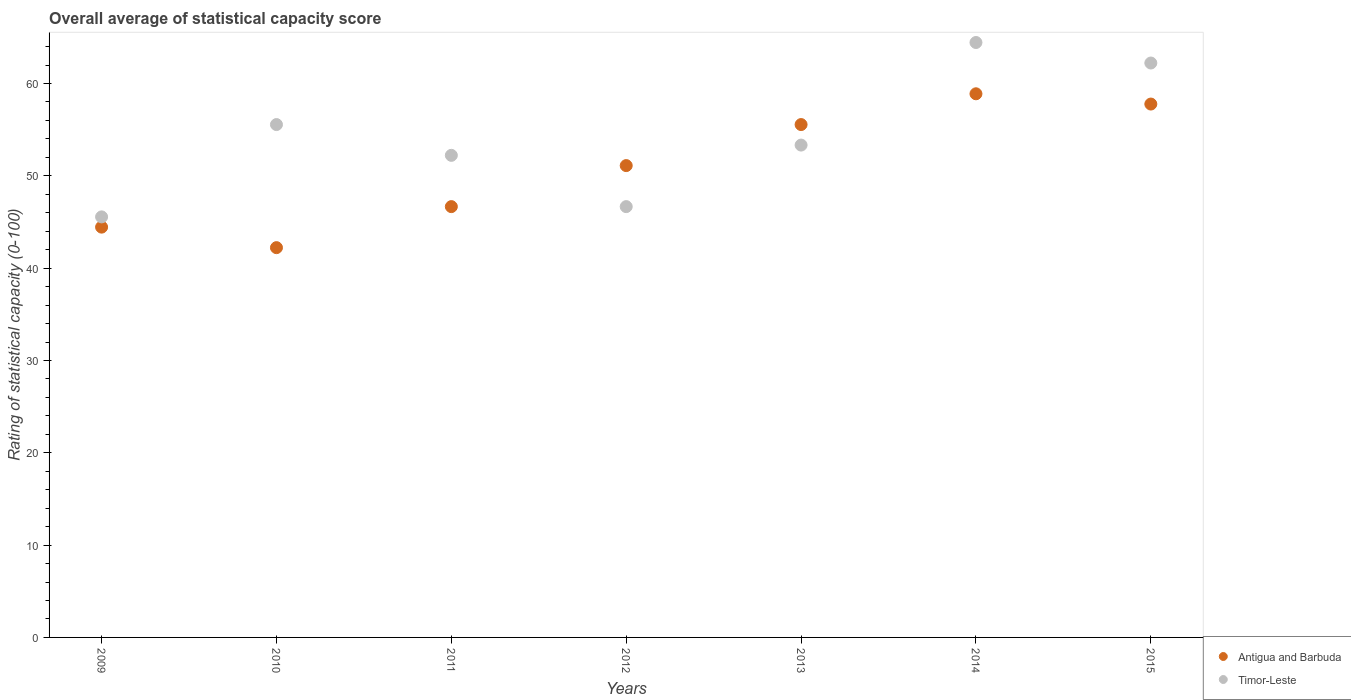How many different coloured dotlines are there?
Your answer should be compact. 2. Is the number of dotlines equal to the number of legend labels?
Keep it short and to the point. Yes. What is the rating of statistical capacity in Timor-Leste in 2011?
Ensure brevity in your answer.  52.22. Across all years, what is the maximum rating of statistical capacity in Antigua and Barbuda?
Your answer should be very brief. 58.89. Across all years, what is the minimum rating of statistical capacity in Antigua and Barbuda?
Your answer should be very brief. 42.22. In which year was the rating of statistical capacity in Antigua and Barbuda maximum?
Make the answer very short. 2014. What is the total rating of statistical capacity in Timor-Leste in the graph?
Your response must be concise. 380. What is the difference between the rating of statistical capacity in Timor-Leste in 2012 and that in 2014?
Your answer should be compact. -17.78. What is the difference between the rating of statistical capacity in Timor-Leste in 2013 and the rating of statistical capacity in Antigua and Barbuda in 2010?
Ensure brevity in your answer.  11.11. What is the average rating of statistical capacity in Timor-Leste per year?
Keep it short and to the point. 54.29. In the year 2013, what is the difference between the rating of statistical capacity in Timor-Leste and rating of statistical capacity in Antigua and Barbuda?
Offer a terse response. -2.22. What is the ratio of the rating of statistical capacity in Timor-Leste in 2009 to that in 2011?
Give a very brief answer. 0.87. Is the difference between the rating of statistical capacity in Timor-Leste in 2013 and 2015 greater than the difference between the rating of statistical capacity in Antigua and Barbuda in 2013 and 2015?
Ensure brevity in your answer.  No. What is the difference between the highest and the second highest rating of statistical capacity in Antigua and Barbuda?
Ensure brevity in your answer.  1.11. What is the difference between the highest and the lowest rating of statistical capacity in Antigua and Barbuda?
Offer a very short reply. 16.67. Is the sum of the rating of statistical capacity in Antigua and Barbuda in 2012 and 2013 greater than the maximum rating of statistical capacity in Timor-Leste across all years?
Keep it short and to the point. Yes. Is the rating of statistical capacity in Timor-Leste strictly greater than the rating of statistical capacity in Antigua and Barbuda over the years?
Keep it short and to the point. No. What is the difference between two consecutive major ticks on the Y-axis?
Keep it short and to the point. 10. Are the values on the major ticks of Y-axis written in scientific E-notation?
Offer a terse response. No. Does the graph contain any zero values?
Provide a succinct answer. No. Does the graph contain grids?
Your response must be concise. No. Where does the legend appear in the graph?
Your response must be concise. Bottom right. How many legend labels are there?
Offer a terse response. 2. How are the legend labels stacked?
Offer a very short reply. Vertical. What is the title of the graph?
Your answer should be very brief. Overall average of statistical capacity score. What is the label or title of the X-axis?
Offer a very short reply. Years. What is the label or title of the Y-axis?
Keep it short and to the point. Rating of statistical capacity (0-100). What is the Rating of statistical capacity (0-100) in Antigua and Barbuda in 2009?
Provide a succinct answer. 44.44. What is the Rating of statistical capacity (0-100) in Timor-Leste in 2009?
Your response must be concise. 45.56. What is the Rating of statistical capacity (0-100) in Antigua and Barbuda in 2010?
Offer a terse response. 42.22. What is the Rating of statistical capacity (0-100) in Timor-Leste in 2010?
Keep it short and to the point. 55.56. What is the Rating of statistical capacity (0-100) in Antigua and Barbuda in 2011?
Ensure brevity in your answer.  46.67. What is the Rating of statistical capacity (0-100) in Timor-Leste in 2011?
Give a very brief answer. 52.22. What is the Rating of statistical capacity (0-100) of Antigua and Barbuda in 2012?
Your response must be concise. 51.11. What is the Rating of statistical capacity (0-100) of Timor-Leste in 2012?
Offer a very short reply. 46.67. What is the Rating of statistical capacity (0-100) of Antigua and Barbuda in 2013?
Keep it short and to the point. 55.56. What is the Rating of statistical capacity (0-100) in Timor-Leste in 2013?
Provide a short and direct response. 53.33. What is the Rating of statistical capacity (0-100) in Antigua and Barbuda in 2014?
Keep it short and to the point. 58.89. What is the Rating of statistical capacity (0-100) of Timor-Leste in 2014?
Ensure brevity in your answer.  64.44. What is the Rating of statistical capacity (0-100) in Antigua and Barbuda in 2015?
Provide a succinct answer. 57.78. What is the Rating of statistical capacity (0-100) in Timor-Leste in 2015?
Provide a succinct answer. 62.22. Across all years, what is the maximum Rating of statistical capacity (0-100) in Antigua and Barbuda?
Keep it short and to the point. 58.89. Across all years, what is the maximum Rating of statistical capacity (0-100) of Timor-Leste?
Make the answer very short. 64.44. Across all years, what is the minimum Rating of statistical capacity (0-100) of Antigua and Barbuda?
Provide a short and direct response. 42.22. Across all years, what is the minimum Rating of statistical capacity (0-100) in Timor-Leste?
Provide a short and direct response. 45.56. What is the total Rating of statistical capacity (0-100) of Antigua and Barbuda in the graph?
Ensure brevity in your answer.  356.67. What is the total Rating of statistical capacity (0-100) of Timor-Leste in the graph?
Keep it short and to the point. 380. What is the difference between the Rating of statistical capacity (0-100) in Antigua and Barbuda in 2009 and that in 2010?
Your response must be concise. 2.22. What is the difference between the Rating of statistical capacity (0-100) in Antigua and Barbuda in 2009 and that in 2011?
Offer a terse response. -2.22. What is the difference between the Rating of statistical capacity (0-100) of Timor-Leste in 2009 and that in 2011?
Your answer should be very brief. -6.67. What is the difference between the Rating of statistical capacity (0-100) in Antigua and Barbuda in 2009 and that in 2012?
Ensure brevity in your answer.  -6.67. What is the difference between the Rating of statistical capacity (0-100) of Timor-Leste in 2009 and that in 2012?
Provide a succinct answer. -1.11. What is the difference between the Rating of statistical capacity (0-100) in Antigua and Barbuda in 2009 and that in 2013?
Provide a succinct answer. -11.11. What is the difference between the Rating of statistical capacity (0-100) in Timor-Leste in 2009 and that in 2013?
Ensure brevity in your answer.  -7.78. What is the difference between the Rating of statistical capacity (0-100) in Antigua and Barbuda in 2009 and that in 2014?
Your response must be concise. -14.44. What is the difference between the Rating of statistical capacity (0-100) of Timor-Leste in 2009 and that in 2014?
Give a very brief answer. -18.89. What is the difference between the Rating of statistical capacity (0-100) in Antigua and Barbuda in 2009 and that in 2015?
Offer a terse response. -13.33. What is the difference between the Rating of statistical capacity (0-100) of Timor-Leste in 2009 and that in 2015?
Make the answer very short. -16.67. What is the difference between the Rating of statistical capacity (0-100) in Antigua and Barbuda in 2010 and that in 2011?
Make the answer very short. -4.44. What is the difference between the Rating of statistical capacity (0-100) in Antigua and Barbuda in 2010 and that in 2012?
Your answer should be compact. -8.89. What is the difference between the Rating of statistical capacity (0-100) in Timor-Leste in 2010 and that in 2012?
Make the answer very short. 8.89. What is the difference between the Rating of statistical capacity (0-100) of Antigua and Barbuda in 2010 and that in 2013?
Your response must be concise. -13.33. What is the difference between the Rating of statistical capacity (0-100) in Timor-Leste in 2010 and that in 2013?
Provide a succinct answer. 2.22. What is the difference between the Rating of statistical capacity (0-100) in Antigua and Barbuda in 2010 and that in 2014?
Ensure brevity in your answer.  -16.67. What is the difference between the Rating of statistical capacity (0-100) in Timor-Leste in 2010 and that in 2014?
Provide a short and direct response. -8.89. What is the difference between the Rating of statistical capacity (0-100) in Antigua and Barbuda in 2010 and that in 2015?
Offer a terse response. -15.56. What is the difference between the Rating of statistical capacity (0-100) of Timor-Leste in 2010 and that in 2015?
Your answer should be very brief. -6.67. What is the difference between the Rating of statistical capacity (0-100) in Antigua and Barbuda in 2011 and that in 2012?
Your answer should be very brief. -4.44. What is the difference between the Rating of statistical capacity (0-100) of Timor-Leste in 2011 and that in 2012?
Your answer should be compact. 5.56. What is the difference between the Rating of statistical capacity (0-100) in Antigua and Barbuda in 2011 and that in 2013?
Provide a short and direct response. -8.89. What is the difference between the Rating of statistical capacity (0-100) in Timor-Leste in 2011 and that in 2013?
Provide a succinct answer. -1.11. What is the difference between the Rating of statistical capacity (0-100) in Antigua and Barbuda in 2011 and that in 2014?
Offer a terse response. -12.22. What is the difference between the Rating of statistical capacity (0-100) of Timor-Leste in 2011 and that in 2014?
Your answer should be compact. -12.22. What is the difference between the Rating of statistical capacity (0-100) of Antigua and Barbuda in 2011 and that in 2015?
Your answer should be very brief. -11.11. What is the difference between the Rating of statistical capacity (0-100) in Timor-Leste in 2011 and that in 2015?
Your answer should be compact. -10. What is the difference between the Rating of statistical capacity (0-100) in Antigua and Barbuda in 2012 and that in 2013?
Make the answer very short. -4.44. What is the difference between the Rating of statistical capacity (0-100) in Timor-Leste in 2012 and that in 2013?
Ensure brevity in your answer.  -6.67. What is the difference between the Rating of statistical capacity (0-100) in Antigua and Barbuda in 2012 and that in 2014?
Offer a very short reply. -7.78. What is the difference between the Rating of statistical capacity (0-100) of Timor-Leste in 2012 and that in 2014?
Your response must be concise. -17.78. What is the difference between the Rating of statistical capacity (0-100) of Antigua and Barbuda in 2012 and that in 2015?
Give a very brief answer. -6.67. What is the difference between the Rating of statistical capacity (0-100) in Timor-Leste in 2012 and that in 2015?
Your answer should be compact. -15.56. What is the difference between the Rating of statistical capacity (0-100) of Timor-Leste in 2013 and that in 2014?
Provide a short and direct response. -11.11. What is the difference between the Rating of statistical capacity (0-100) of Antigua and Barbuda in 2013 and that in 2015?
Offer a very short reply. -2.22. What is the difference between the Rating of statistical capacity (0-100) in Timor-Leste in 2013 and that in 2015?
Make the answer very short. -8.89. What is the difference between the Rating of statistical capacity (0-100) in Timor-Leste in 2014 and that in 2015?
Your answer should be very brief. 2.22. What is the difference between the Rating of statistical capacity (0-100) of Antigua and Barbuda in 2009 and the Rating of statistical capacity (0-100) of Timor-Leste in 2010?
Keep it short and to the point. -11.11. What is the difference between the Rating of statistical capacity (0-100) in Antigua and Barbuda in 2009 and the Rating of statistical capacity (0-100) in Timor-Leste in 2011?
Keep it short and to the point. -7.78. What is the difference between the Rating of statistical capacity (0-100) in Antigua and Barbuda in 2009 and the Rating of statistical capacity (0-100) in Timor-Leste in 2012?
Make the answer very short. -2.22. What is the difference between the Rating of statistical capacity (0-100) of Antigua and Barbuda in 2009 and the Rating of statistical capacity (0-100) of Timor-Leste in 2013?
Your answer should be very brief. -8.89. What is the difference between the Rating of statistical capacity (0-100) in Antigua and Barbuda in 2009 and the Rating of statistical capacity (0-100) in Timor-Leste in 2014?
Give a very brief answer. -20. What is the difference between the Rating of statistical capacity (0-100) in Antigua and Barbuda in 2009 and the Rating of statistical capacity (0-100) in Timor-Leste in 2015?
Provide a short and direct response. -17.78. What is the difference between the Rating of statistical capacity (0-100) of Antigua and Barbuda in 2010 and the Rating of statistical capacity (0-100) of Timor-Leste in 2011?
Offer a very short reply. -10. What is the difference between the Rating of statistical capacity (0-100) in Antigua and Barbuda in 2010 and the Rating of statistical capacity (0-100) in Timor-Leste in 2012?
Offer a terse response. -4.44. What is the difference between the Rating of statistical capacity (0-100) of Antigua and Barbuda in 2010 and the Rating of statistical capacity (0-100) of Timor-Leste in 2013?
Your answer should be very brief. -11.11. What is the difference between the Rating of statistical capacity (0-100) of Antigua and Barbuda in 2010 and the Rating of statistical capacity (0-100) of Timor-Leste in 2014?
Ensure brevity in your answer.  -22.22. What is the difference between the Rating of statistical capacity (0-100) in Antigua and Barbuda in 2010 and the Rating of statistical capacity (0-100) in Timor-Leste in 2015?
Your response must be concise. -20. What is the difference between the Rating of statistical capacity (0-100) in Antigua and Barbuda in 2011 and the Rating of statistical capacity (0-100) in Timor-Leste in 2013?
Ensure brevity in your answer.  -6.67. What is the difference between the Rating of statistical capacity (0-100) in Antigua and Barbuda in 2011 and the Rating of statistical capacity (0-100) in Timor-Leste in 2014?
Give a very brief answer. -17.78. What is the difference between the Rating of statistical capacity (0-100) of Antigua and Barbuda in 2011 and the Rating of statistical capacity (0-100) of Timor-Leste in 2015?
Your response must be concise. -15.56. What is the difference between the Rating of statistical capacity (0-100) of Antigua and Barbuda in 2012 and the Rating of statistical capacity (0-100) of Timor-Leste in 2013?
Ensure brevity in your answer.  -2.22. What is the difference between the Rating of statistical capacity (0-100) in Antigua and Barbuda in 2012 and the Rating of statistical capacity (0-100) in Timor-Leste in 2014?
Offer a very short reply. -13.33. What is the difference between the Rating of statistical capacity (0-100) of Antigua and Barbuda in 2012 and the Rating of statistical capacity (0-100) of Timor-Leste in 2015?
Your response must be concise. -11.11. What is the difference between the Rating of statistical capacity (0-100) of Antigua and Barbuda in 2013 and the Rating of statistical capacity (0-100) of Timor-Leste in 2014?
Provide a succinct answer. -8.89. What is the difference between the Rating of statistical capacity (0-100) of Antigua and Barbuda in 2013 and the Rating of statistical capacity (0-100) of Timor-Leste in 2015?
Offer a very short reply. -6.67. What is the difference between the Rating of statistical capacity (0-100) in Antigua and Barbuda in 2014 and the Rating of statistical capacity (0-100) in Timor-Leste in 2015?
Your answer should be compact. -3.33. What is the average Rating of statistical capacity (0-100) of Antigua and Barbuda per year?
Provide a succinct answer. 50.95. What is the average Rating of statistical capacity (0-100) of Timor-Leste per year?
Offer a very short reply. 54.29. In the year 2009, what is the difference between the Rating of statistical capacity (0-100) in Antigua and Barbuda and Rating of statistical capacity (0-100) in Timor-Leste?
Ensure brevity in your answer.  -1.11. In the year 2010, what is the difference between the Rating of statistical capacity (0-100) of Antigua and Barbuda and Rating of statistical capacity (0-100) of Timor-Leste?
Offer a terse response. -13.33. In the year 2011, what is the difference between the Rating of statistical capacity (0-100) of Antigua and Barbuda and Rating of statistical capacity (0-100) of Timor-Leste?
Offer a terse response. -5.56. In the year 2012, what is the difference between the Rating of statistical capacity (0-100) of Antigua and Barbuda and Rating of statistical capacity (0-100) of Timor-Leste?
Make the answer very short. 4.44. In the year 2013, what is the difference between the Rating of statistical capacity (0-100) in Antigua and Barbuda and Rating of statistical capacity (0-100) in Timor-Leste?
Offer a terse response. 2.22. In the year 2014, what is the difference between the Rating of statistical capacity (0-100) of Antigua and Barbuda and Rating of statistical capacity (0-100) of Timor-Leste?
Offer a terse response. -5.56. In the year 2015, what is the difference between the Rating of statistical capacity (0-100) in Antigua and Barbuda and Rating of statistical capacity (0-100) in Timor-Leste?
Your answer should be compact. -4.44. What is the ratio of the Rating of statistical capacity (0-100) in Antigua and Barbuda in 2009 to that in 2010?
Your answer should be very brief. 1.05. What is the ratio of the Rating of statistical capacity (0-100) of Timor-Leste in 2009 to that in 2010?
Your answer should be very brief. 0.82. What is the ratio of the Rating of statistical capacity (0-100) in Antigua and Barbuda in 2009 to that in 2011?
Provide a succinct answer. 0.95. What is the ratio of the Rating of statistical capacity (0-100) in Timor-Leste in 2009 to that in 2011?
Offer a very short reply. 0.87. What is the ratio of the Rating of statistical capacity (0-100) in Antigua and Barbuda in 2009 to that in 2012?
Provide a short and direct response. 0.87. What is the ratio of the Rating of statistical capacity (0-100) in Timor-Leste in 2009 to that in 2012?
Your response must be concise. 0.98. What is the ratio of the Rating of statistical capacity (0-100) of Timor-Leste in 2009 to that in 2013?
Provide a succinct answer. 0.85. What is the ratio of the Rating of statistical capacity (0-100) of Antigua and Barbuda in 2009 to that in 2014?
Provide a succinct answer. 0.75. What is the ratio of the Rating of statistical capacity (0-100) in Timor-Leste in 2009 to that in 2014?
Provide a succinct answer. 0.71. What is the ratio of the Rating of statistical capacity (0-100) in Antigua and Barbuda in 2009 to that in 2015?
Give a very brief answer. 0.77. What is the ratio of the Rating of statistical capacity (0-100) of Timor-Leste in 2009 to that in 2015?
Your answer should be very brief. 0.73. What is the ratio of the Rating of statistical capacity (0-100) of Antigua and Barbuda in 2010 to that in 2011?
Offer a terse response. 0.9. What is the ratio of the Rating of statistical capacity (0-100) in Timor-Leste in 2010 to that in 2011?
Ensure brevity in your answer.  1.06. What is the ratio of the Rating of statistical capacity (0-100) in Antigua and Barbuda in 2010 to that in 2012?
Your answer should be very brief. 0.83. What is the ratio of the Rating of statistical capacity (0-100) in Timor-Leste in 2010 to that in 2012?
Offer a terse response. 1.19. What is the ratio of the Rating of statistical capacity (0-100) of Antigua and Barbuda in 2010 to that in 2013?
Give a very brief answer. 0.76. What is the ratio of the Rating of statistical capacity (0-100) of Timor-Leste in 2010 to that in 2013?
Your answer should be very brief. 1.04. What is the ratio of the Rating of statistical capacity (0-100) in Antigua and Barbuda in 2010 to that in 2014?
Provide a short and direct response. 0.72. What is the ratio of the Rating of statistical capacity (0-100) of Timor-Leste in 2010 to that in 2014?
Your answer should be very brief. 0.86. What is the ratio of the Rating of statistical capacity (0-100) in Antigua and Barbuda in 2010 to that in 2015?
Offer a very short reply. 0.73. What is the ratio of the Rating of statistical capacity (0-100) in Timor-Leste in 2010 to that in 2015?
Keep it short and to the point. 0.89. What is the ratio of the Rating of statistical capacity (0-100) in Antigua and Barbuda in 2011 to that in 2012?
Give a very brief answer. 0.91. What is the ratio of the Rating of statistical capacity (0-100) in Timor-Leste in 2011 to that in 2012?
Make the answer very short. 1.12. What is the ratio of the Rating of statistical capacity (0-100) of Antigua and Barbuda in 2011 to that in 2013?
Your answer should be very brief. 0.84. What is the ratio of the Rating of statistical capacity (0-100) in Timor-Leste in 2011 to that in 2013?
Your answer should be very brief. 0.98. What is the ratio of the Rating of statistical capacity (0-100) of Antigua and Barbuda in 2011 to that in 2014?
Provide a succinct answer. 0.79. What is the ratio of the Rating of statistical capacity (0-100) in Timor-Leste in 2011 to that in 2014?
Keep it short and to the point. 0.81. What is the ratio of the Rating of statistical capacity (0-100) of Antigua and Barbuda in 2011 to that in 2015?
Offer a very short reply. 0.81. What is the ratio of the Rating of statistical capacity (0-100) of Timor-Leste in 2011 to that in 2015?
Offer a terse response. 0.84. What is the ratio of the Rating of statistical capacity (0-100) in Antigua and Barbuda in 2012 to that in 2013?
Provide a short and direct response. 0.92. What is the ratio of the Rating of statistical capacity (0-100) of Antigua and Barbuda in 2012 to that in 2014?
Ensure brevity in your answer.  0.87. What is the ratio of the Rating of statistical capacity (0-100) of Timor-Leste in 2012 to that in 2014?
Offer a terse response. 0.72. What is the ratio of the Rating of statistical capacity (0-100) in Antigua and Barbuda in 2012 to that in 2015?
Ensure brevity in your answer.  0.88. What is the ratio of the Rating of statistical capacity (0-100) in Timor-Leste in 2012 to that in 2015?
Provide a short and direct response. 0.75. What is the ratio of the Rating of statistical capacity (0-100) in Antigua and Barbuda in 2013 to that in 2014?
Offer a very short reply. 0.94. What is the ratio of the Rating of statistical capacity (0-100) in Timor-Leste in 2013 to that in 2014?
Give a very brief answer. 0.83. What is the ratio of the Rating of statistical capacity (0-100) in Antigua and Barbuda in 2013 to that in 2015?
Give a very brief answer. 0.96. What is the ratio of the Rating of statistical capacity (0-100) of Antigua and Barbuda in 2014 to that in 2015?
Your response must be concise. 1.02. What is the ratio of the Rating of statistical capacity (0-100) of Timor-Leste in 2014 to that in 2015?
Provide a short and direct response. 1.04. What is the difference between the highest and the second highest Rating of statistical capacity (0-100) of Antigua and Barbuda?
Make the answer very short. 1.11. What is the difference between the highest and the second highest Rating of statistical capacity (0-100) of Timor-Leste?
Give a very brief answer. 2.22. What is the difference between the highest and the lowest Rating of statistical capacity (0-100) in Antigua and Barbuda?
Ensure brevity in your answer.  16.67. What is the difference between the highest and the lowest Rating of statistical capacity (0-100) of Timor-Leste?
Offer a very short reply. 18.89. 